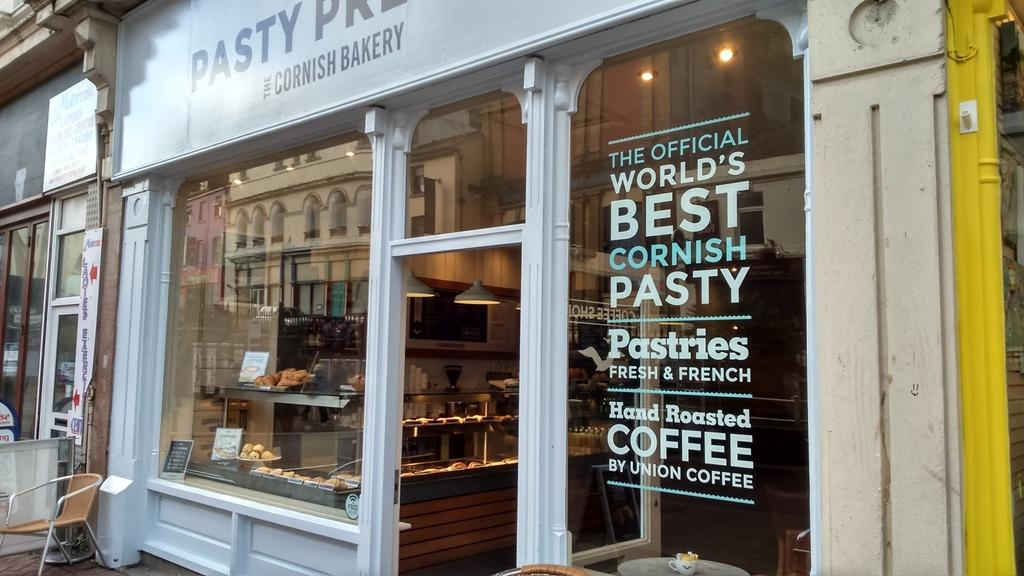<image>
Present a compact description of the photo's key features. the outside of a storefront for pastries and coffee and cornish pasty 